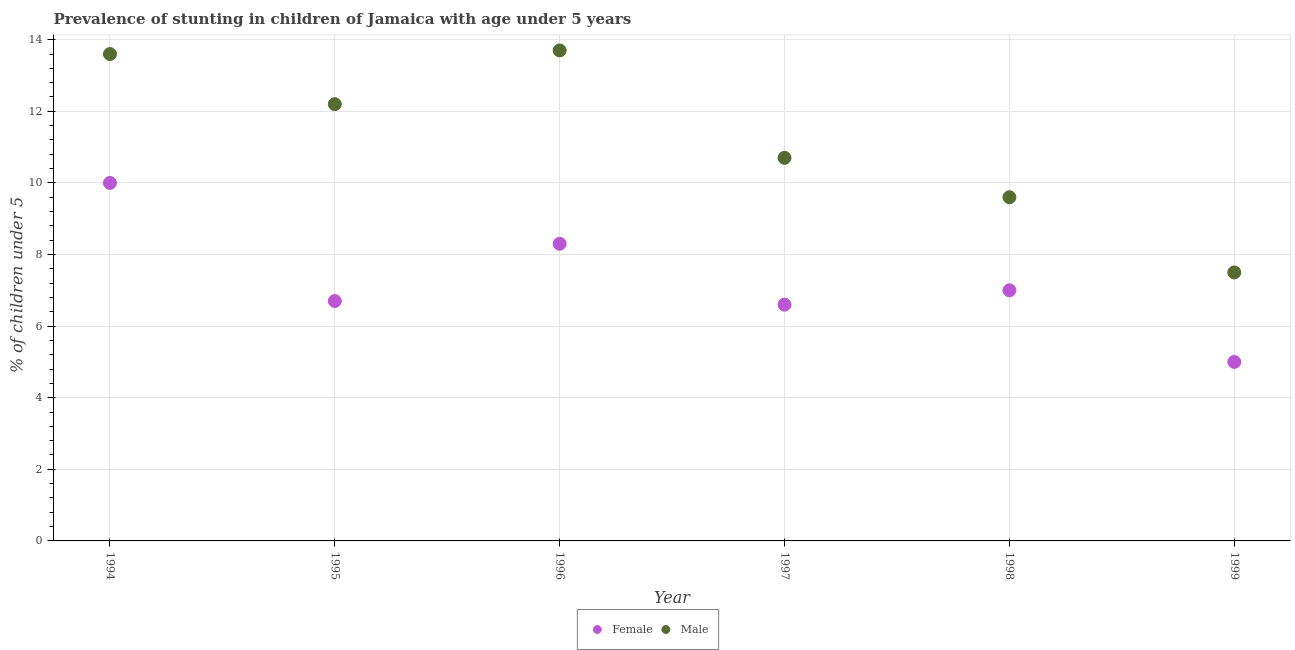What is the percentage of stunted male children in 1994?
Your response must be concise. 13.6. In which year was the percentage of stunted female children minimum?
Your response must be concise. 1999. What is the total percentage of stunted male children in the graph?
Your response must be concise. 67.3. What is the difference between the percentage of stunted female children in 1995 and that in 1999?
Make the answer very short. 1.7. What is the difference between the percentage of stunted female children in 1997 and the percentage of stunted male children in 1996?
Provide a succinct answer. -7.1. What is the average percentage of stunted female children per year?
Your answer should be very brief. 7.27. In the year 1995, what is the difference between the percentage of stunted female children and percentage of stunted male children?
Keep it short and to the point. -5.5. What is the ratio of the percentage of stunted female children in 1996 to that in 1997?
Ensure brevity in your answer.  1.26. What is the difference between the highest and the second highest percentage of stunted male children?
Your answer should be very brief. 0.1. What is the difference between the highest and the lowest percentage of stunted female children?
Your answer should be compact. 5. In how many years, is the percentage of stunted male children greater than the average percentage of stunted male children taken over all years?
Keep it short and to the point. 3. Does the percentage of stunted female children monotonically increase over the years?
Your answer should be very brief. No. Is the percentage of stunted female children strictly greater than the percentage of stunted male children over the years?
Provide a succinct answer. No. How many years are there in the graph?
Your answer should be very brief. 6. Are the values on the major ticks of Y-axis written in scientific E-notation?
Provide a succinct answer. No. Does the graph contain grids?
Make the answer very short. Yes. Where does the legend appear in the graph?
Ensure brevity in your answer.  Bottom center. How many legend labels are there?
Offer a very short reply. 2. What is the title of the graph?
Make the answer very short. Prevalence of stunting in children of Jamaica with age under 5 years. Does "National Visitors" appear as one of the legend labels in the graph?
Provide a short and direct response. No. What is the label or title of the Y-axis?
Ensure brevity in your answer.   % of children under 5. What is the  % of children under 5 in Female in 1994?
Provide a short and direct response. 10. What is the  % of children under 5 in Male in 1994?
Offer a terse response. 13.6. What is the  % of children under 5 in Female in 1995?
Your answer should be very brief. 6.7. What is the  % of children under 5 of Male in 1995?
Offer a terse response. 12.2. What is the  % of children under 5 of Female in 1996?
Keep it short and to the point. 8.3. What is the  % of children under 5 in Male in 1996?
Your response must be concise. 13.7. What is the  % of children under 5 in Female in 1997?
Give a very brief answer. 6.6. What is the  % of children under 5 in Male in 1997?
Give a very brief answer. 10.7. What is the  % of children under 5 of Male in 1998?
Keep it short and to the point. 9.6. What is the  % of children under 5 in Female in 1999?
Offer a terse response. 5. Across all years, what is the maximum  % of children under 5 of Female?
Ensure brevity in your answer.  10. Across all years, what is the maximum  % of children under 5 of Male?
Your answer should be very brief. 13.7. What is the total  % of children under 5 in Female in the graph?
Make the answer very short. 43.6. What is the total  % of children under 5 in Male in the graph?
Provide a succinct answer. 67.3. What is the difference between the  % of children under 5 in Female in 1994 and that in 1995?
Offer a very short reply. 3.3. What is the difference between the  % of children under 5 in Male in 1994 and that in 1998?
Your answer should be compact. 4. What is the difference between the  % of children under 5 of Female in 1995 and that in 1996?
Make the answer very short. -1.6. What is the difference between the  % of children under 5 of Female in 1995 and that in 1997?
Keep it short and to the point. 0.1. What is the difference between the  % of children under 5 in Female in 1995 and that in 1998?
Make the answer very short. -0.3. What is the difference between the  % of children under 5 of Male in 1995 and that in 1999?
Provide a succinct answer. 4.7. What is the difference between the  % of children under 5 in Female in 1996 and that in 1997?
Make the answer very short. 1.7. What is the difference between the  % of children under 5 in Male in 1996 and that in 1997?
Ensure brevity in your answer.  3. What is the difference between the  % of children under 5 in Male in 1997 and that in 1998?
Provide a short and direct response. 1.1. What is the difference between the  % of children under 5 in Female in 1997 and that in 1999?
Offer a very short reply. 1.6. What is the difference between the  % of children under 5 of Male in 1997 and that in 1999?
Provide a short and direct response. 3.2. What is the difference between the  % of children under 5 in Male in 1998 and that in 1999?
Make the answer very short. 2.1. What is the difference between the  % of children under 5 of Female in 1994 and the  % of children under 5 of Male in 1995?
Provide a succinct answer. -2.2. What is the difference between the  % of children under 5 in Female in 1994 and the  % of children under 5 in Male in 1997?
Provide a succinct answer. -0.7. What is the difference between the  % of children under 5 in Female in 1994 and the  % of children under 5 in Male in 1998?
Keep it short and to the point. 0.4. What is the difference between the  % of children under 5 of Female in 1995 and the  % of children under 5 of Male in 1997?
Ensure brevity in your answer.  -4. What is the difference between the  % of children under 5 in Female in 1995 and the  % of children under 5 in Male in 1999?
Provide a succinct answer. -0.8. What is the difference between the  % of children under 5 of Female in 1996 and the  % of children under 5 of Male in 1997?
Provide a short and direct response. -2.4. What is the difference between the  % of children under 5 in Female in 1997 and the  % of children under 5 in Male in 1998?
Your response must be concise. -3. What is the average  % of children under 5 of Female per year?
Offer a terse response. 7.27. What is the average  % of children under 5 in Male per year?
Provide a short and direct response. 11.22. In the year 1994, what is the difference between the  % of children under 5 of Female and  % of children under 5 of Male?
Offer a terse response. -3.6. In the year 1995, what is the difference between the  % of children under 5 in Female and  % of children under 5 in Male?
Ensure brevity in your answer.  -5.5. In the year 1998, what is the difference between the  % of children under 5 of Female and  % of children under 5 of Male?
Your response must be concise. -2.6. In the year 1999, what is the difference between the  % of children under 5 in Female and  % of children under 5 in Male?
Your answer should be compact. -2.5. What is the ratio of the  % of children under 5 of Female in 1994 to that in 1995?
Your answer should be very brief. 1.49. What is the ratio of the  % of children under 5 of Male in 1994 to that in 1995?
Your response must be concise. 1.11. What is the ratio of the  % of children under 5 of Female in 1994 to that in 1996?
Offer a very short reply. 1.2. What is the ratio of the  % of children under 5 of Female in 1994 to that in 1997?
Ensure brevity in your answer.  1.52. What is the ratio of the  % of children under 5 in Male in 1994 to that in 1997?
Give a very brief answer. 1.27. What is the ratio of the  % of children under 5 in Female in 1994 to that in 1998?
Make the answer very short. 1.43. What is the ratio of the  % of children under 5 of Male in 1994 to that in 1998?
Offer a very short reply. 1.42. What is the ratio of the  % of children under 5 in Female in 1994 to that in 1999?
Offer a very short reply. 2. What is the ratio of the  % of children under 5 in Male in 1994 to that in 1999?
Give a very brief answer. 1.81. What is the ratio of the  % of children under 5 of Female in 1995 to that in 1996?
Ensure brevity in your answer.  0.81. What is the ratio of the  % of children under 5 of Male in 1995 to that in 1996?
Provide a short and direct response. 0.89. What is the ratio of the  % of children under 5 of Female in 1995 to that in 1997?
Keep it short and to the point. 1.02. What is the ratio of the  % of children under 5 of Male in 1995 to that in 1997?
Give a very brief answer. 1.14. What is the ratio of the  % of children under 5 in Female in 1995 to that in 1998?
Give a very brief answer. 0.96. What is the ratio of the  % of children under 5 of Male in 1995 to that in 1998?
Your response must be concise. 1.27. What is the ratio of the  % of children under 5 in Female in 1995 to that in 1999?
Your answer should be compact. 1.34. What is the ratio of the  % of children under 5 of Male in 1995 to that in 1999?
Ensure brevity in your answer.  1.63. What is the ratio of the  % of children under 5 in Female in 1996 to that in 1997?
Your answer should be compact. 1.26. What is the ratio of the  % of children under 5 of Male in 1996 to that in 1997?
Provide a succinct answer. 1.28. What is the ratio of the  % of children under 5 of Female in 1996 to that in 1998?
Make the answer very short. 1.19. What is the ratio of the  % of children under 5 in Male in 1996 to that in 1998?
Your answer should be very brief. 1.43. What is the ratio of the  % of children under 5 of Female in 1996 to that in 1999?
Give a very brief answer. 1.66. What is the ratio of the  % of children under 5 in Male in 1996 to that in 1999?
Give a very brief answer. 1.83. What is the ratio of the  % of children under 5 of Female in 1997 to that in 1998?
Offer a terse response. 0.94. What is the ratio of the  % of children under 5 in Male in 1997 to that in 1998?
Make the answer very short. 1.11. What is the ratio of the  % of children under 5 in Female in 1997 to that in 1999?
Give a very brief answer. 1.32. What is the ratio of the  % of children under 5 of Male in 1997 to that in 1999?
Offer a terse response. 1.43. What is the ratio of the  % of children under 5 of Male in 1998 to that in 1999?
Offer a terse response. 1.28. What is the difference between the highest and the second highest  % of children under 5 in Male?
Your answer should be compact. 0.1. What is the difference between the highest and the lowest  % of children under 5 of Female?
Give a very brief answer. 5. What is the difference between the highest and the lowest  % of children under 5 of Male?
Your answer should be very brief. 6.2. 